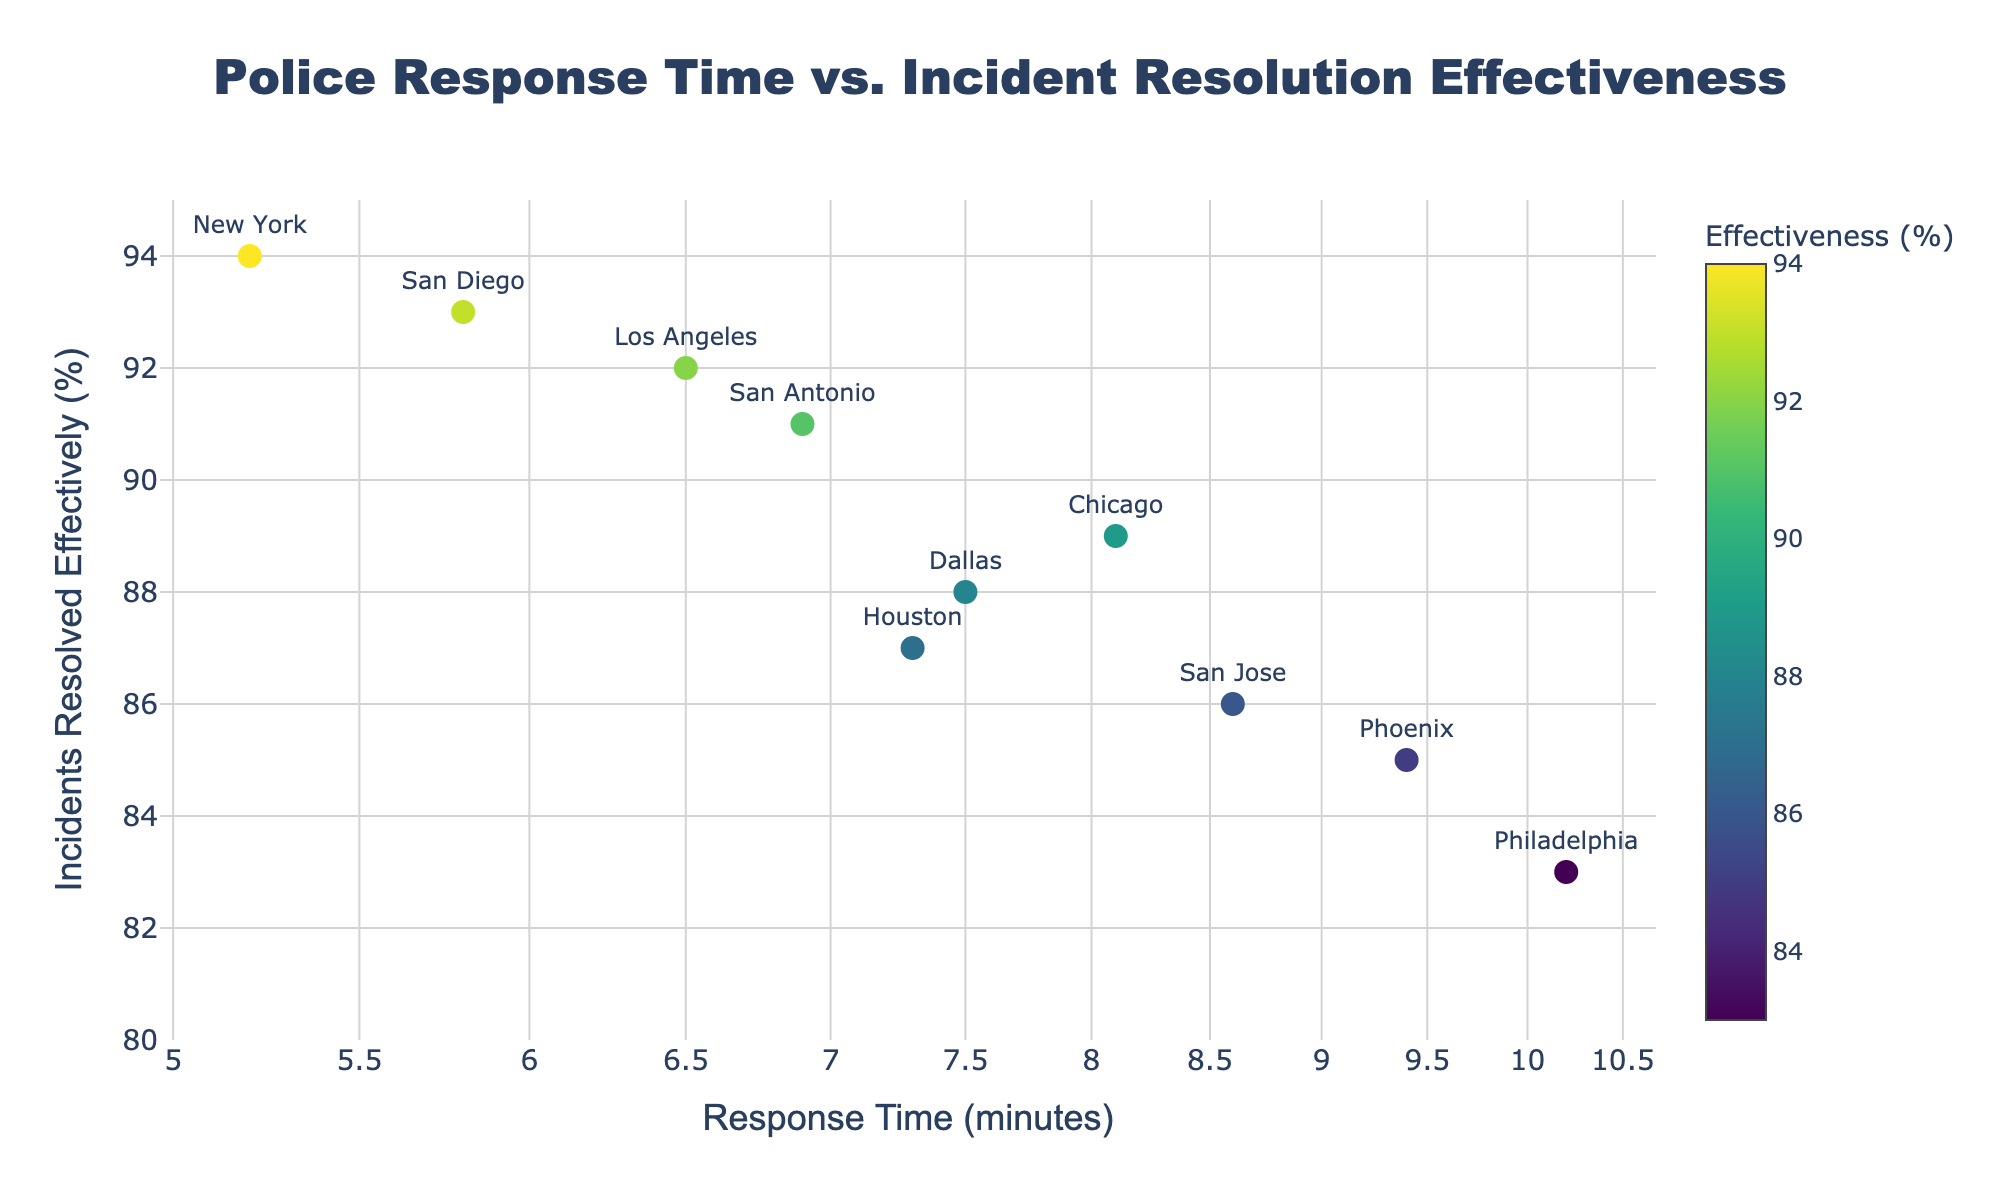What is the title of the scatter plot? The title of the scatter plot is typically displayed at the top of the figure. In this case, it should read "Police Response Time vs. Incident Resolution Effectiveness."
Answer: Police Response Time vs. Incident Resolution Effectiveness How many jurisdictions are represented in the scatter plot? Each data point represents one jurisdiction, and the plot shows markers with names next to them. By counting these markers or names, we can determine the number. The data indicates 10 jurisdictions are included.
Answer: 10 Which jurisdiction has the shortest response time? The x-axis represents response times on a logarithmic scale, and the shortest response time will be at the leftmost point. According to the data, New York has the shortest response time of 5.2 minutes.
Answer: New York Which jurisdiction has the highest incident resolution effectiveness? The y-axis represents incident resolution effectiveness. The highest point on this axis corresponds to the highest effectiveness. Based on the data, New York has the highest effectiveness at 94%.
Answer: New York What is the average response time across all jurisdictions? To find the average response time, sum all response times and divide by the number of jurisdictions: (6.5 + 5.2 + 8.1 + 7.3 + 9.4 + 10.2 + 6.9 + 5.8 + 7.5 + 8.6) / 10 = 7.55 minutes.
Answer: 7.55 minutes How does the effectiveness of San Antonio compare to that of Houston? Look for the y-axis positions of San Antonio and Houston. San Antonio has an incident resolution effectiveness of 91%, while Houston has 87%.
Answer: San Antonio Which two jurisdictions have the most similar response times? Identify the two closest values on the x-axis. Based on the data, Houston (7.3 minutes) and Dallas (7.5 minutes) have the most similar response times.
Answer: Houston and Dallas Is there a visible trend between response time and incident resolution effectiveness? Evaluate the scatter plot for a general pattern: a scatter plot showing higher effectiveness with lower response time indicates a trend. Here, lower response times tend to correlate with higher effectiveness, though there are exceptions.
Answer: Generally inverse Which jurisdiction has a response time between 8 and 9 minutes and the lowest effectiveness? Locate data points between 8 and 9 minutes on the x-axis and identify which one is lowest on the y-axis. San Jose has a response time of 8.6 minutes and an effectiveness of 86%.
Answer: San Jose What are the response times for jurisdictions with over 90% effectiveness? Directly examining both x-axis and y-axis indicators, identify the jurisdictions with y-values over 90% and note their x-values. Los Angeles (6.5), New York (5.2), San Antonio (6.9), and San Diego (5.8) meet this criterion.
Answer: 6.5, 5.2, 6.9, 5.8 